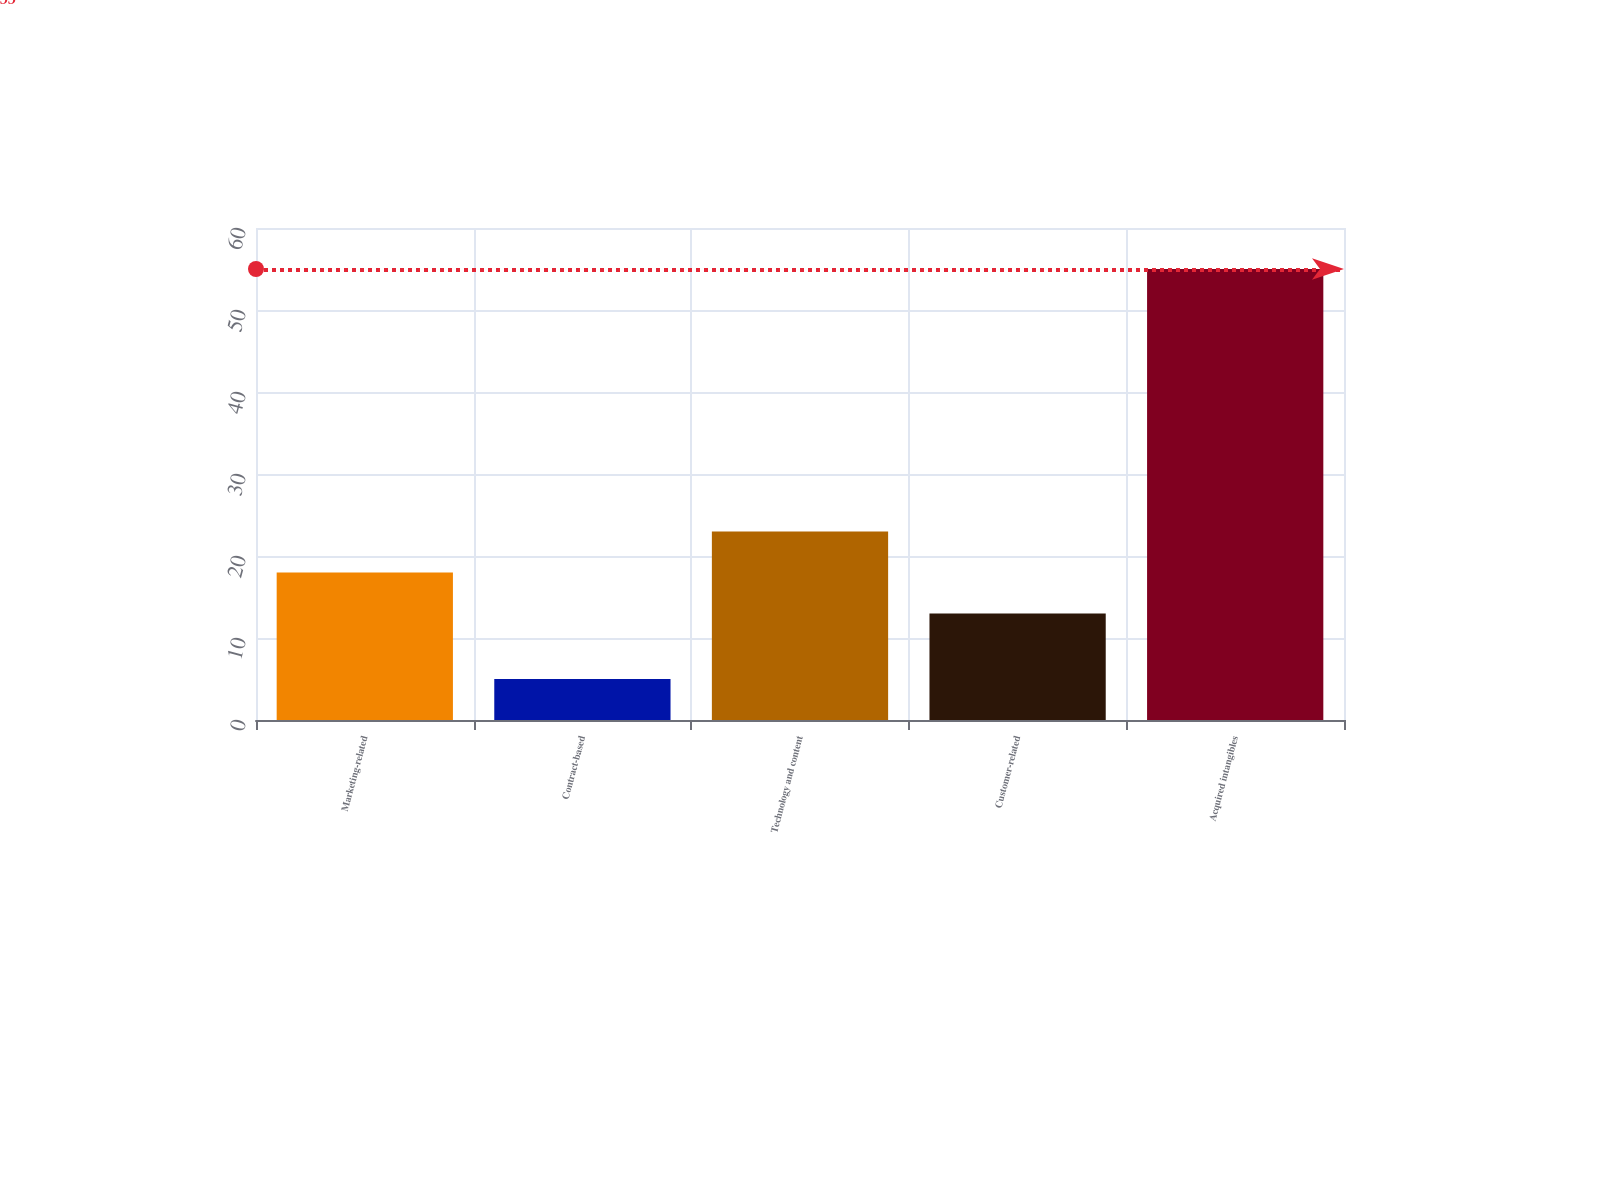Convert chart to OTSL. <chart><loc_0><loc_0><loc_500><loc_500><bar_chart><fcel>Marketing-related<fcel>Contract-based<fcel>Technology and content<fcel>Customer-related<fcel>Acquired intangibles<nl><fcel>18<fcel>5<fcel>23<fcel>13<fcel>55<nl></chart> 